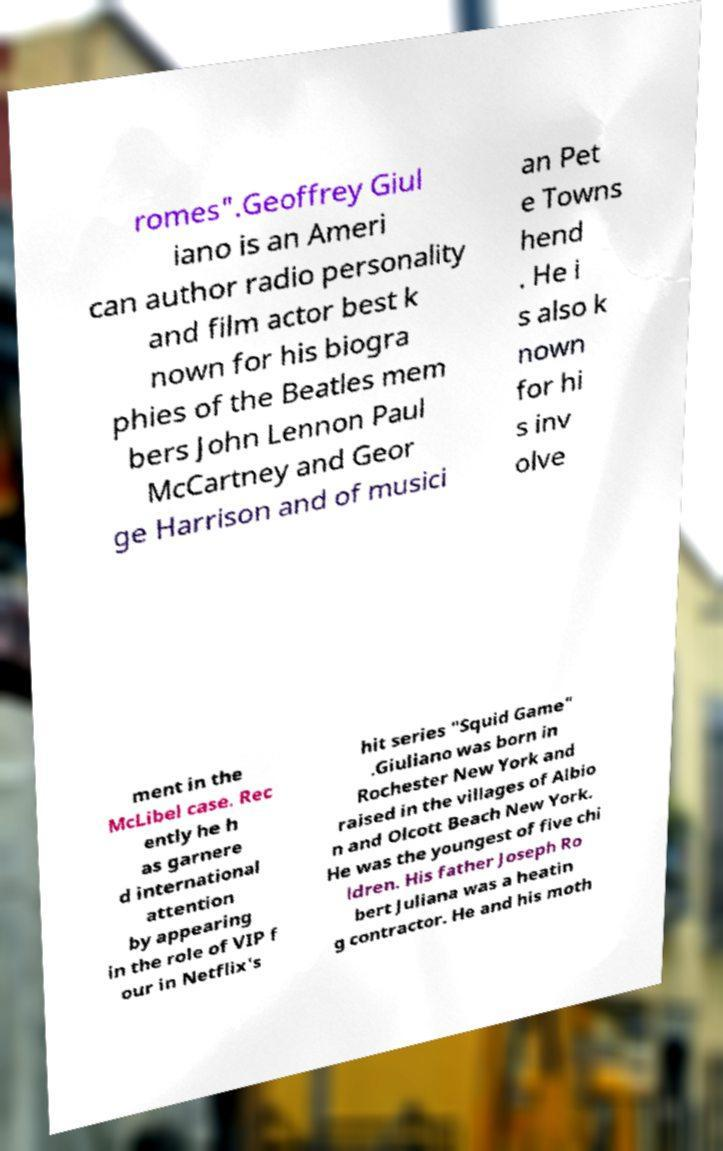Please identify and transcribe the text found in this image. romes".Geoffrey Giul iano is an Ameri can author radio personality and film actor best k nown for his biogra phies of the Beatles mem bers John Lennon Paul McCartney and Geor ge Harrison and of musici an Pet e Towns hend . He i s also k nown for hi s inv olve ment in the McLibel case. Rec ently he h as garnere d international attention by appearing in the role of VIP f our in Netflix's hit series "Squid Game" .Giuliano was born in Rochester New York and raised in the villages of Albio n and Olcott Beach New York. He was the youngest of five chi ldren. His father Joseph Ro bert Juliana was a heatin g contractor. He and his moth 